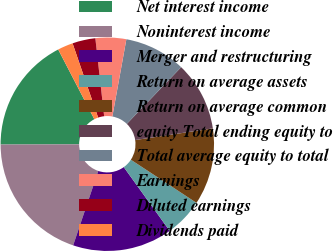Convert chart to OTSL. <chart><loc_0><loc_0><loc_500><loc_500><pie_chart><fcel>Net interest income<fcel>Noninterest income<fcel>Merger and restructuring<fcel>Return on average assets<fcel>Return on average common<fcel>equity Total ending equity to<fcel>Total average equity to total<fcel>Earnings<fcel>Diluted earnings<fcel>Dividends paid<nl><fcel>17.44%<fcel>19.77%<fcel>15.12%<fcel>5.81%<fcel>11.63%<fcel>10.47%<fcel>9.3%<fcel>4.65%<fcel>3.49%<fcel>2.33%<nl></chart> 